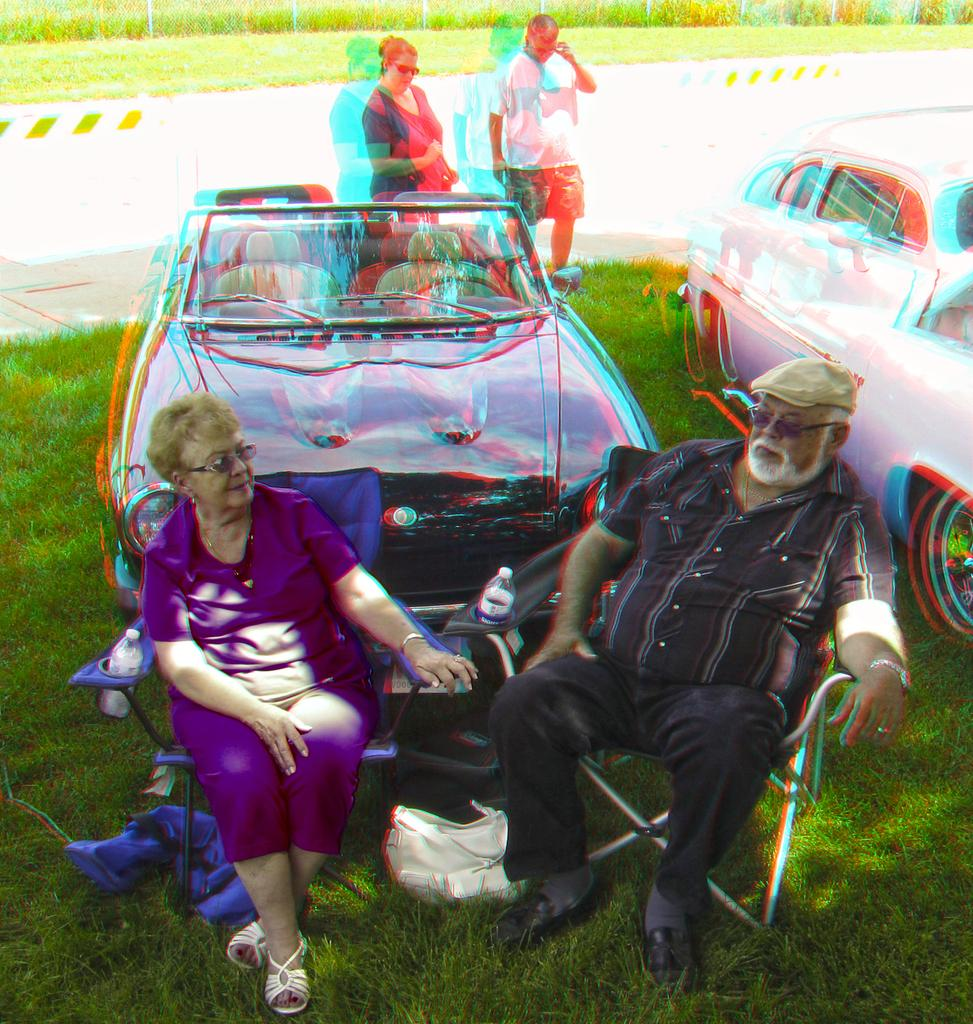How many vehicles are in the image? There are two vehicles in the image. What are the people in the image doing? Two persons are sitting on chairs, and two persons are standing on the grass in the image. What can be seen in the background of the image? There is a road, fences, grass, and a few plants visible in the background of the image. What type of ice can be seen melting on the rail in the image? There is no ice or rail present in the image. How many women are visible in the image? The image does not specify the gender of the people, so we cannot determine the number of women present. 